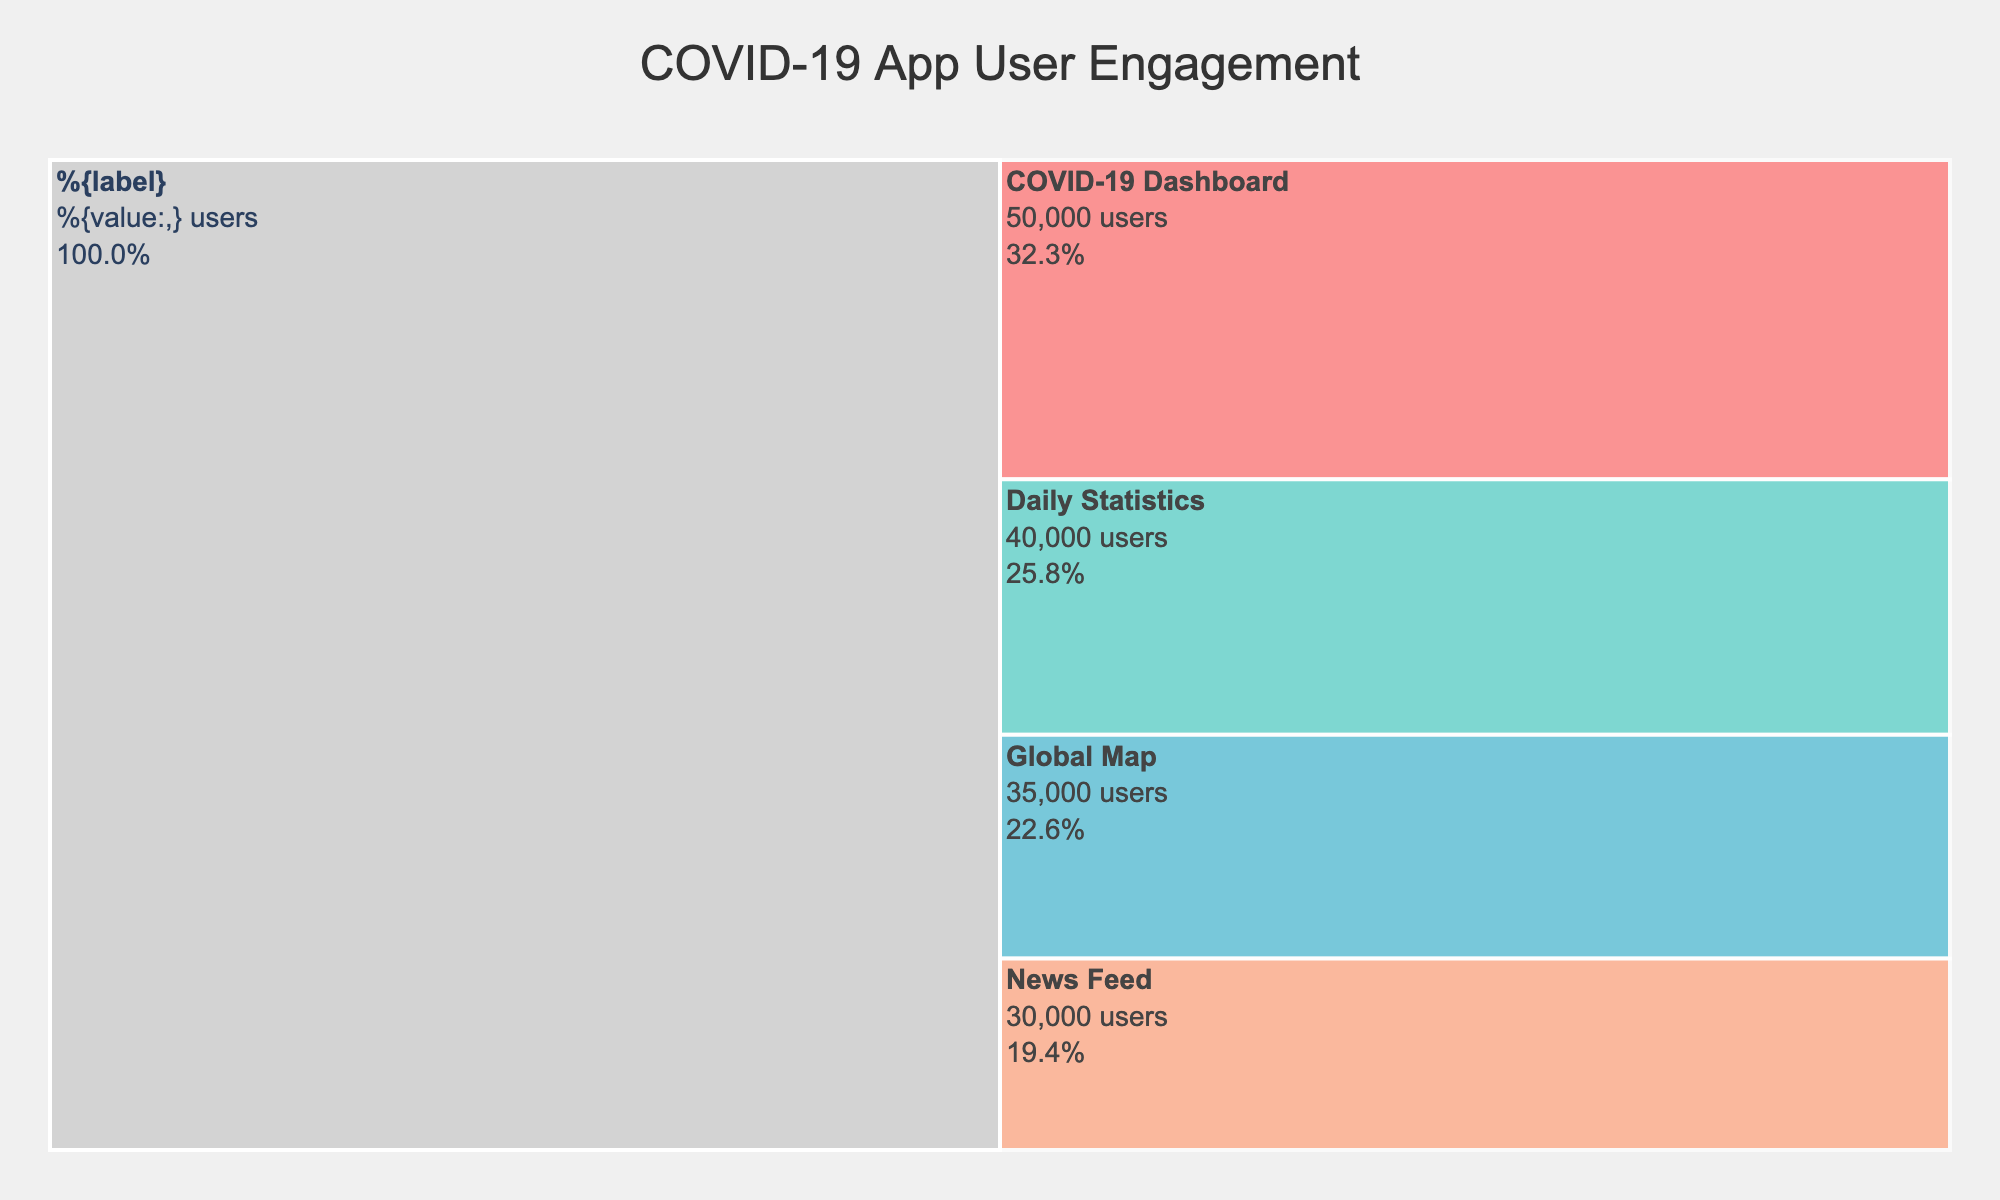Which feature has the highest user engagement? The feature with the highest user engagement in the Icicle chart is the one with the largest segment. It is marked in one of the prominent colors and positioned at the top of the hierarchy with the largest percentage value in the diagram, indicating it has the most users.
Answer: COVID-19 Dashboard How many users does the Global Map feature have? The Global Map feature can be identified visually. The number of users is indicated inside the segment for the Global Map feature.
Answer: 35,000 Which feature has the least amount of user engagement? The feature with the least user engagement is the one with the smallest percentage value and segment area. It is marked lowest in the visual hierarchy of the Icicle chart.
Answer: News Feed How much total time is spent on the Daily Statistics and News Feed features combined? To calculate the total time spent on both features, add the time spent values for Daily Statistics and News Feed. According to the chart, Daily Statistics is 600 minutes and News Feed is 200 minutes.
Answer: 800 minutes Which feature has more users: Daily Statistics or Global Map? By examining the chart and comparing the sizes and values within the segments for Daily Statistics and Global Map, Daily Statistics has 40,000 users whereas Global Map has 35,000.
Answer: Daily Statistics What is the approximate percentage of users that engage with the COVID-19 Dashboard feature? The percentage is directly indicated within the segment for COVID-19 Dashboard. It is calculated as the number of users for COVID-19 Dashboard divided by the total number of users and converted to a percentage.
Answer: 33.3% If new users double the current engagement for the News Feed feature, what will be the new user count for News Feed? To find the new user count, double the current number of users for News Feed, which is 30,000. Thus, the new user count will be 30,000 * 2.
Answer: 60,000 What is the total number of users engaging with the app? The total number of users can be found by summing the values of users for all features: 50,000 (COVID-19 Dashboard) + 40,000 (Daily Statistics) + 35,000 (Global Map) + 30,000 (News Feed).
Answer: 155,000 How does the user engagement of the COVID-19 Dashboard compare to the News Feed? The COVID-19 Dashboard has a higher user engagement as shown by its larger percentage and segment size in the Icicle chart compared to News Feed. Specifically, COVID-19 Dashboard has 50,000 users while News Feed has 30,000.
Answer: Higher What color represents the Daily Statistics feature? The chart uses distinctive color coding for different features. The Daily Statistics feature can be identified by its specific color among the provided custom color scale.
Answer: #4ECDC4 